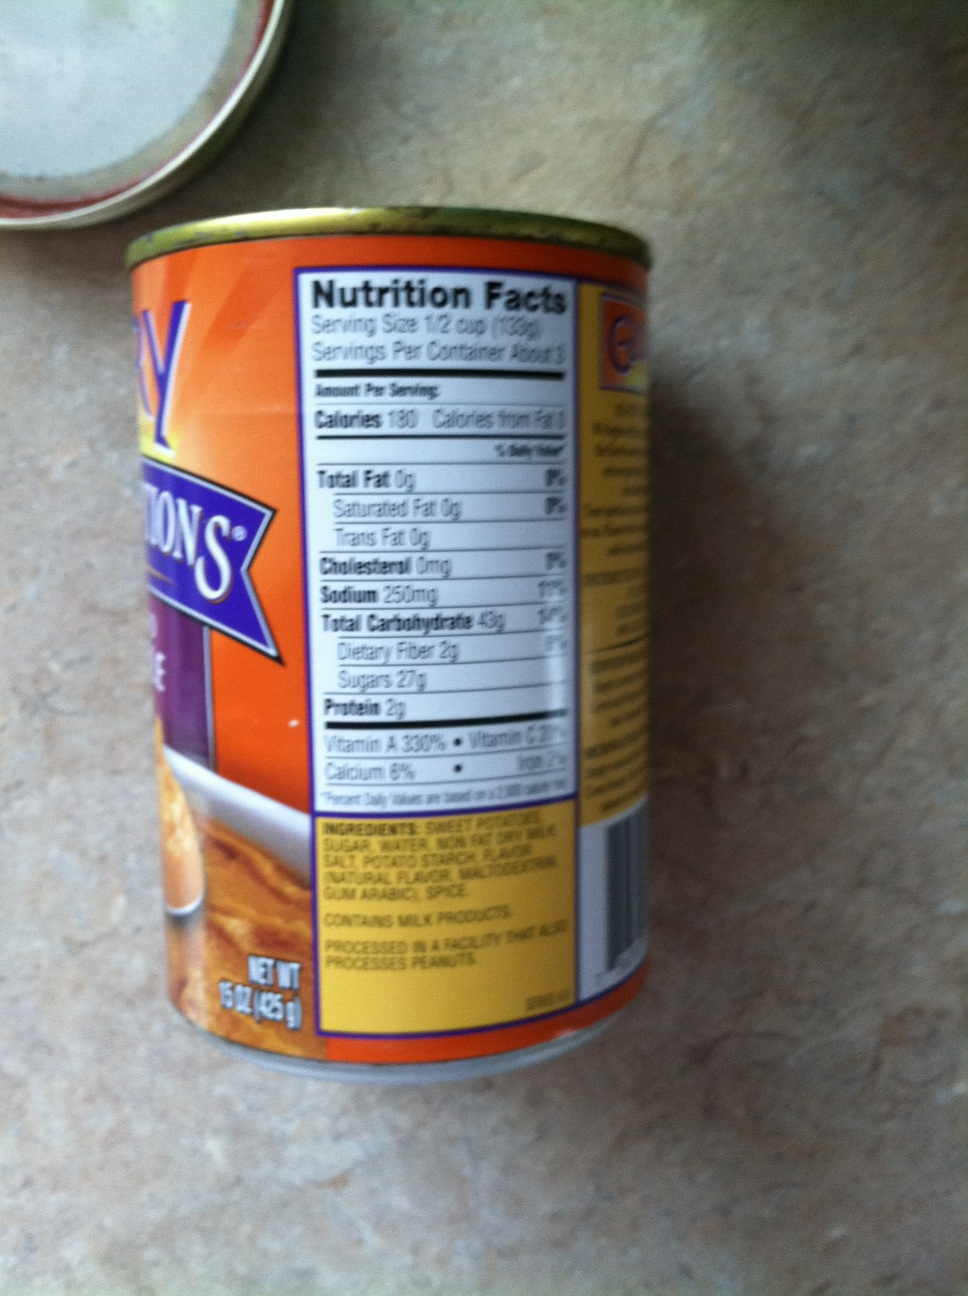If this tin had a secret story, what would it be? This tin of sweet potatoes has a fascinating secret story. It was once part of a unique batch grown with care on a small, enchanted farm known only to a select few. The farmer, known as the 'Potato Whisperer,' tends to these sweet potatoes with special care, using secret techniques passed down through generations to imbue them with an otherworldly taste. This very tin ended up in the hands of a renowned chef who, inspired by its extraordinary flavor, created a world-famous dish that captivated the palates of diners and brought joy to those who tasted it. 